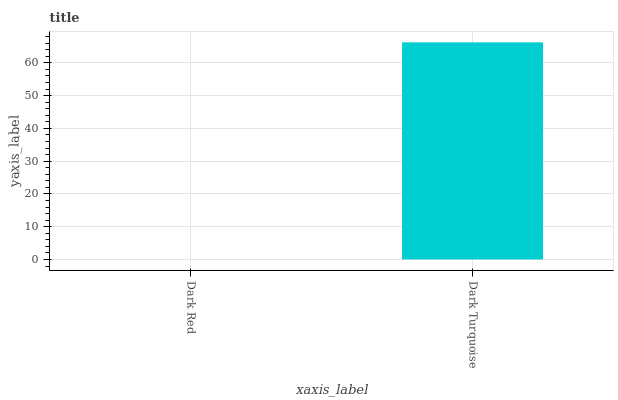Is Dark Red the minimum?
Answer yes or no. Yes. Is Dark Turquoise the maximum?
Answer yes or no. Yes. Is Dark Turquoise the minimum?
Answer yes or no. No. Is Dark Turquoise greater than Dark Red?
Answer yes or no. Yes. Is Dark Red less than Dark Turquoise?
Answer yes or no. Yes. Is Dark Red greater than Dark Turquoise?
Answer yes or no. No. Is Dark Turquoise less than Dark Red?
Answer yes or no. No. Is Dark Turquoise the high median?
Answer yes or no. Yes. Is Dark Red the low median?
Answer yes or no. Yes. Is Dark Red the high median?
Answer yes or no. No. Is Dark Turquoise the low median?
Answer yes or no. No. 